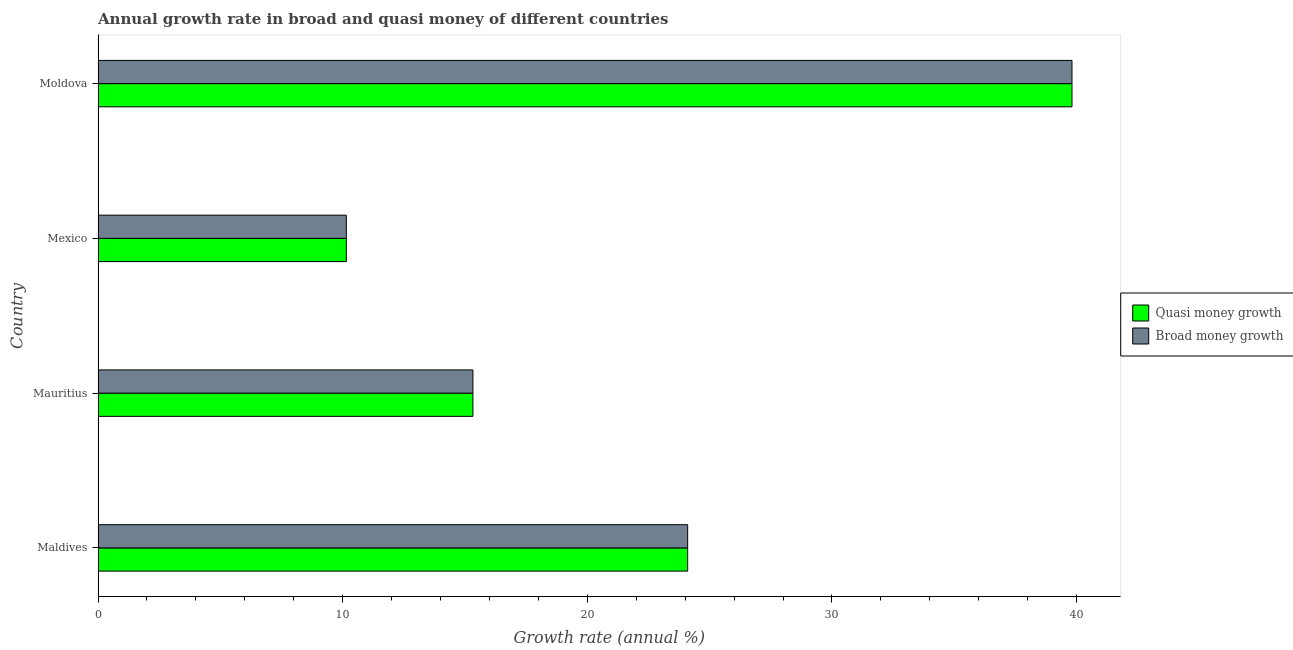How many different coloured bars are there?
Offer a terse response. 2. How many groups of bars are there?
Provide a short and direct response. 4. How many bars are there on the 1st tick from the top?
Ensure brevity in your answer.  2. What is the label of the 1st group of bars from the top?
Offer a terse response. Moldova. What is the annual growth rate in broad money in Maldives?
Offer a terse response. 24.1. Across all countries, what is the maximum annual growth rate in quasi money?
Ensure brevity in your answer.  39.81. Across all countries, what is the minimum annual growth rate in broad money?
Your response must be concise. 10.15. In which country was the annual growth rate in broad money maximum?
Provide a succinct answer. Moldova. In which country was the annual growth rate in quasi money minimum?
Offer a terse response. Mexico. What is the total annual growth rate in broad money in the graph?
Your answer should be very brief. 89.38. What is the difference between the annual growth rate in broad money in Maldives and that in Mexico?
Your answer should be very brief. 13.95. What is the difference between the annual growth rate in quasi money in Mexico and the annual growth rate in broad money in Maldives?
Offer a terse response. -13.95. What is the average annual growth rate in quasi money per country?
Your response must be concise. 22.34. What is the ratio of the annual growth rate in quasi money in Mauritius to that in Moldova?
Give a very brief answer. 0.39. Is the annual growth rate in broad money in Mexico less than that in Moldova?
Keep it short and to the point. Yes. Is the difference between the annual growth rate in quasi money in Maldives and Moldova greater than the difference between the annual growth rate in broad money in Maldives and Moldova?
Keep it short and to the point. No. What is the difference between the highest and the second highest annual growth rate in broad money?
Provide a succinct answer. 15.71. What is the difference between the highest and the lowest annual growth rate in broad money?
Provide a short and direct response. 29.66. What does the 2nd bar from the top in Moldova represents?
Your answer should be very brief. Quasi money growth. What does the 1st bar from the bottom in Maldives represents?
Provide a short and direct response. Quasi money growth. How many bars are there?
Ensure brevity in your answer.  8. How many countries are there in the graph?
Your response must be concise. 4. What is the difference between two consecutive major ticks on the X-axis?
Offer a very short reply. 10. Are the values on the major ticks of X-axis written in scientific E-notation?
Ensure brevity in your answer.  No. Does the graph contain any zero values?
Your answer should be compact. No. Does the graph contain grids?
Ensure brevity in your answer.  No. Where does the legend appear in the graph?
Your response must be concise. Center right. How are the legend labels stacked?
Provide a succinct answer. Vertical. What is the title of the graph?
Provide a succinct answer. Annual growth rate in broad and quasi money of different countries. What is the label or title of the X-axis?
Give a very brief answer. Growth rate (annual %). What is the Growth rate (annual %) of Quasi money growth in Maldives?
Provide a succinct answer. 24.1. What is the Growth rate (annual %) of Broad money growth in Maldives?
Give a very brief answer. 24.1. What is the Growth rate (annual %) in Quasi money growth in Mauritius?
Offer a terse response. 15.32. What is the Growth rate (annual %) of Broad money growth in Mauritius?
Make the answer very short. 15.32. What is the Growth rate (annual %) of Quasi money growth in Mexico?
Keep it short and to the point. 10.15. What is the Growth rate (annual %) in Broad money growth in Mexico?
Make the answer very short. 10.15. What is the Growth rate (annual %) in Quasi money growth in Moldova?
Make the answer very short. 39.81. What is the Growth rate (annual %) in Broad money growth in Moldova?
Offer a very short reply. 39.81. Across all countries, what is the maximum Growth rate (annual %) of Quasi money growth?
Give a very brief answer. 39.81. Across all countries, what is the maximum Growth rate (annual %) in Broad money growth?
Offer a terse response. 39.81. Across all countries, what is the minimum Growth rate (annual %) in Quasi money growth?
Your answer should be compact. 10.15. Across all countries, what is the minimum Growth rate (annual %) of Broad money growth?
Keep it short and to the point. 10.15. What is the total Growth rate (annual %) of Quasi money growth in the graph?
Provide a short and direct response. 89.38. What is the total Growth rate (annual %) in Broad money growth in the graph?
Offer a very short reply. 89.38. What is the difference between the Growth rate (annual %) of Quasi money growth in Maldives and that in Mauritius?
Provide a short and direct response. 8.78. What is the difference between the Growth rate (annual %) in Broad money growth in Maldives and that in Mauritius?
Your answer should be compact. 8.78. What is the difference between the Growth rate (annual %) in Quasi money growth in Maldives and that in Mexico?
Make the answer very short. 13.95. What is the difference between the Growth rate (annual %) of Broad money growth in Maldives and that in Mexico?
Your response must be concise. 13.95. What is the difference between the Growth rate (annual %) in Quasi money growth in Maldives and that in Moldova?
Offer a terse response. -15.71. What is the difference between the Growth rate (annual %) of Broad money growth in Maldives and that in Moldova?
Provide a short and direct response. -15.71. What is the difference between the Growth rate (annual %) in Quasi money growth in Mauritius and that in Mexico?
Provide a succinct answer. 5.17. What is the difference between the Growth rate (annual %) in Broad money growth in Mauritius and that in Mexico?
Give a very brief answer. 5.17. What is the difference between the Growth rate (annual %) in Quasi money growth in Mauritius and that in Moldova?
Provide a short and direct response. -24.49. What is the difference between the Growth rate (annual %) in Broad money growth in Mauritius and that in Moldova?
Your answer should be very brief. -24.49. What is the difference between the Growth rate (annual %) of Quasi money growth in Mexico and that in Moldova?
Your response must be concise. -29.66. What is the difference between the Growth rate (annual %) of Broad money growth in Mexico and that in Moldova?
Provide a succinct answer. -29.66. What is the difference between the Growth rate (annual %) of Quasi money growth in Maldives and the Growth rate (annual %) of Broad money growth in Mauritius?
Give a very brief answer. 8.78. What is the difference between the Growth rate (annual %) in Quasi money growth in Maldives and the Growth rate (annual %) in Broad money growth in Mexico?
Keep it short and to the point. 13.95. What is the difference between the Growth rate (annual %) of Quasi money growth in Maldives and the Growth rate (annual %) of Broad money growth in Moldova?
Give a very brief answer. -15.71. What is the difference between the Growth rate (annual %) of Quasi money growth in Mauritius and the Growth rate (annual %) of Broad money growth in Mexico?
Provide a succinct answer. 5.17. What is the difference between the Growth rate (annual %) of Quasi money growth in Mauritius and the Growth rate (annual %) of Broad money growth in Moldova?
Keep it short and to the point. -24.49. What is the difference between the Growth rate (annual %) in Quasi money growth in Mexico and the Growth rate (annual %) in Broad money growth in Moldova?
Provide a succinct answer. -29.66. What is the average Growth rate (annual %) of Quasi money growth per country?
Offer a very short reply. 22.35. What is the average Growth rate (annual %) of Broad money growth per country?
Give a very brief answer. 22.35. What is the difference between the Growth rate (annual %) in Quasi money growth and Growth rate (annual %) in Broad money growth in Maldives?
Offer a very short reply. 0. What is the difference between the Growth rate (annual %) in Quasi money growth and Growth rate (annual %) in Broad money growth in Mauritius?
Offer a terse response. 0. What is the difference between the Growth rate (annual %) of Quasi money growth and Growth rate (annual %) of Broad money growth in Mexico?
Your answer should be very brief. 0. What is the difference between the Growth rate (annual %) in Quasi money growth and Growth rate (annual %) in Broad money growth in Moldova?
Offer a terse response. 0. What is the ratio of the Growth rate (annual %) of Quasi money growth in Maldives to that in Mauritius?
Your answer should be very brief. 1.57. What is the ratio of the Growth rate (annual %) in Broad money growth in Maldives to that in Mauritius?
Ensure brevity in your answer.  1.57. What is the ratio of the Growth rate (annual %) in Quasi money growth in Maldives to that in Mexico?
Make the answer very short. 2.38. What is the ratio of the Growth rate (annual %) of Broad money growth in Maldives to that in Mexico?
Your answer should be very brief. 2.38. What is the ratio of the Growth rate (annual %) of Quasi money growth in Maldives to that in Moldova?
Provide a succinct answer. 0.61. What is the ratio of the Growth rate (annual %) of Broad money growth in Maldives to that in Moldova?
Your answer should be very brief. 0.61. What is the ratio of the Growth rate (annual %) in Quasi money growth in Mauritius to that in Mexico?
Your answer should be compact. 1.51. What is the ratio of the Growth rate (annual %) in Broad money growth in Mauritius to that in Mexico?
Your answer should be compact. 1.51. What is the ratio of the Growth rate (annual %) in Quasi money growth in Mauritius to that in Moldova?
Offer a terse response. 0.38. What is the ratio of the Growth rate (annual %) in Broad money growth in Mauritius to that in Moldova?
Your answer should be compact. 0.38. What is the ratio of the Growth rate (annual %) of Quasi money growth in Mexico to that in Moldova?
Offer a terse response. 0.25. What is the ratio of the Growth rate (annual %) in Broad money growth in Mexico to that in Moldova?
Offer a terse response. 0.25. What is the difference between the highest and the second highest Growth rate (annual %) of Quasi money growth?
Offer a very short reply. 15.71. What is the difference between the highest and the second highest Growth rate (annual %) of Broad money growth?
Provide a short and direct response. 15.71. What is the difference between the highest and the lowest Growth rate (annual %) of Quasi money growth?
Your answer should be very brief. 29.66. What is the difference between the highest and the lowest Growth rate (annual %) of Broad money growth?
Make the answer very short. 29.66. 